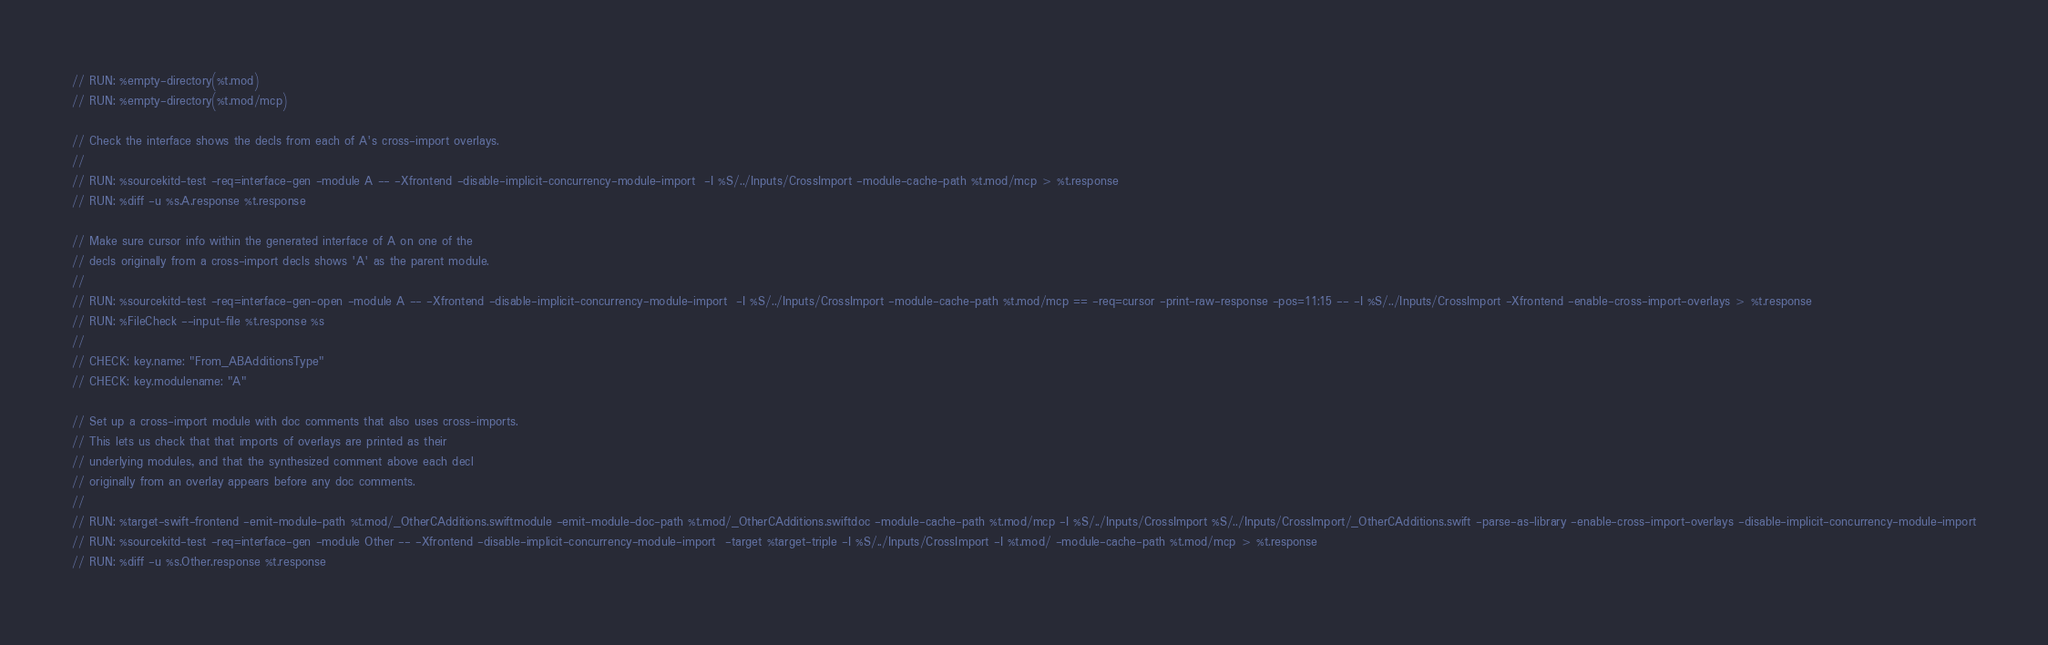<code> <loc_0><loc_0><loc_500><loc_500><_Swift_>// RUN: %empty-directory(%t.mod)
// RUN: %empty-directory(%t.mod/mcp)

// Check the interface shows the decls from each of A's cross-import overlays.
//
// RUN: %sourcekitd-test -req=interface-gen -module A -- -Xfrontend -disable-implicit-concurrency-module-import  -I %S/../Inputs/CrossImport -module-cache-path %t.mod/mcp > %t.response
// RUN: %diff -u %s.A.response %t.response

// Make sure cursor info within the generated interface of A on one of the
// decls originally from a cross-import decls shows 'A' as the parent module.
//
// RUN: %sourcekitd-test -req=interface-gen-open -module A -- -Xfrontend -disable-implicit-concurrency-module-import  -I %S/../Inputs/CrossImport -module-cache-path %t.mod/mcp == -req=cursor -print-raw-response -pos=11:15 -- -I %S/../Inputs/CrossImport -Xfrontend -enable-cross-import-overlays > %t.response
// RUN: %FileCheck --input-file %t.response %s
//
// CHECK: key.name: "From_ABAdditionsType"
// CHECK: key.modulename: "A"

// Set up a cross-import module with doc comments that also uses cross-imports.
// This lets us check that that imports of overlays are printed as their
// underlying modules, and that the synthesized comment above each decl
// originally from an overlay appears before any doc comments.
//
// RUN: %target-swift-frontend -emit-module-path %t.mod/_OtherCAdditions.swiftmodule -emit-module-doc-path %t.mod/_OtherCAdditions.swiftdoc -module-cache-path %t.mod/mcp -I %S/../Inputs/CrossImport %S/../Inputs/CrossImport/_OtherCAdditions.swift -parse-as-library -enable-cross-import-overlays -disable-implicit-concurrency-module-import
// RUN: %sourcekitd-test -req=interface-gen -module Other -- -Xfrontend -disable-implicit-concurrency-module-import  -target %target-triple -I %S/../Inputs/CrossImport -I %t.mod/ -module-cache-path %t.mod/mcp > %t.response
// RUN: %diff -u %s.Other.response %t.response
</code> 